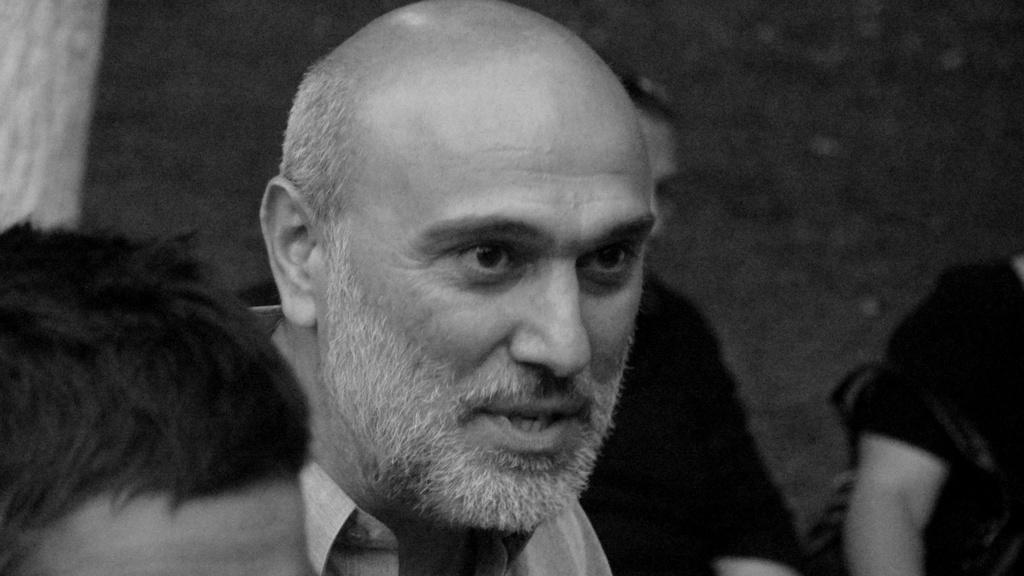How would you summarize this image in a sentence or two? In this picture we can observe a man with bald head and beard. We can observe people in this picture. This is a black and white image. 